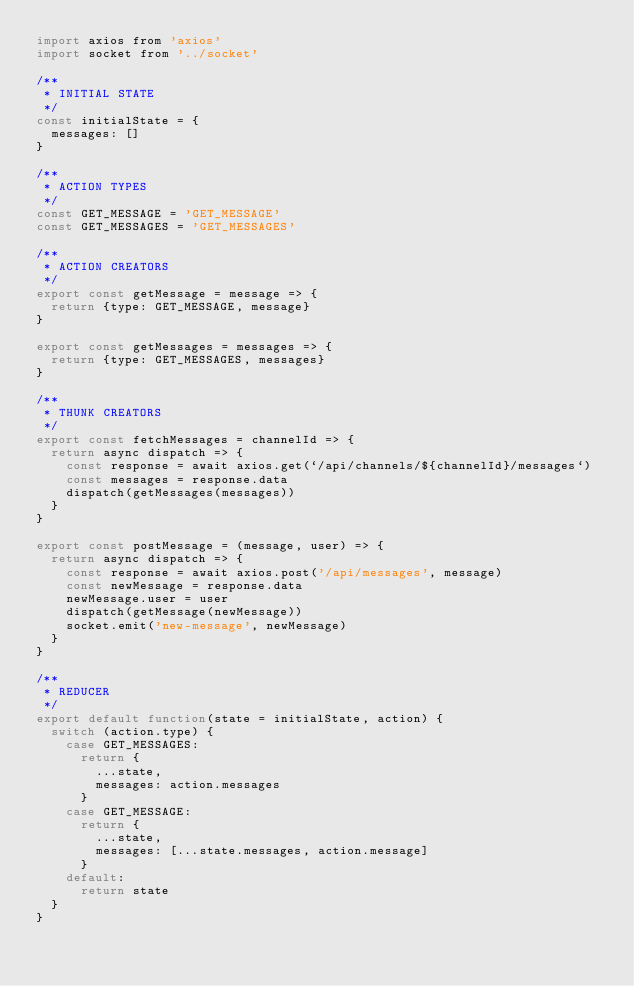<code> <loc_0><loc_0><loc_500><loc_500><_JavaScript_>import axios from 'axios'
import socket from '../socket'

/**
 * INITIAL STATE
 */
const initialState = {
  messages: []
}

/**
 * ACTION TYPES
 */
const GET_MESSAGE = 'GET_MESSAGE'
const GET_MESSAGES = 'GET_MESSAGES'

/**
 * ACTION CREATORS
 */
export const getMessage = message => {
  return {type: GET_MESSAGE, message}
}

export const getMessages = messages => {
  return {type: GET_MESSAGES, messages}
}

/**
 * THUNK CREATORS
 */
export const fetchMessages = channelId => {
  return async dispatch => {
    const response = await axios.get(`/api/channels/${channelId}/messages`)
    const messages = response.data
    dispatch(getMessages(messages))
  }
}

export const postMessage = (message, user) => {
  return async dispatch => {
    const response = await axios.post('/api/messages', message)
    const newMessage = response.data
    newMessage.user = user
    dispatch(getMessage(newMessage))
    socket.emit('new-message', newMessage)
  }
}

/**
 * REDUCER
 */
export default function(state = initialState, action) {
  switch (action.type) {
    case GET_MESSAGES:
      return {
        ...state,
        messages: action.messages
      }
    case GET_MESSAGE:
      return {
        ...state,
        messages: [...state.messages, action.message]
      }
    default:
      return state
  }
}
</code> 